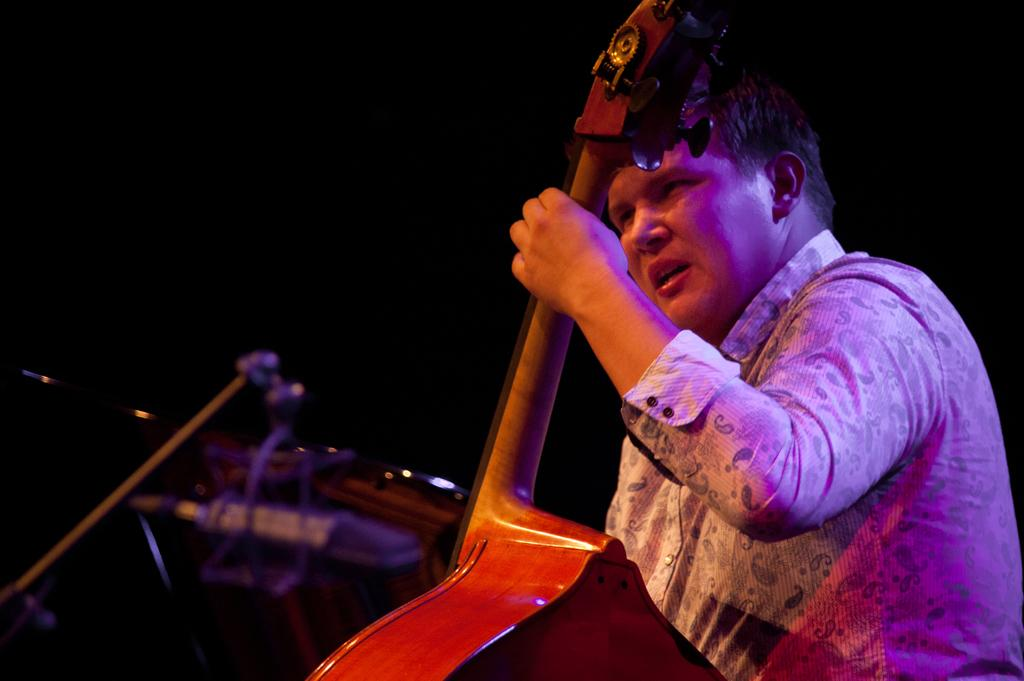Who is the main subject in the image? There is a man in the image. How is the man in the image being emphasized? The man is highlighted in the image. What is the man holding in the image? The man is holding a musical instrument. What type of quill is the man using to write a surprise note in the image? There is no quill or note present in the image; the man is holding a musical instrument. 